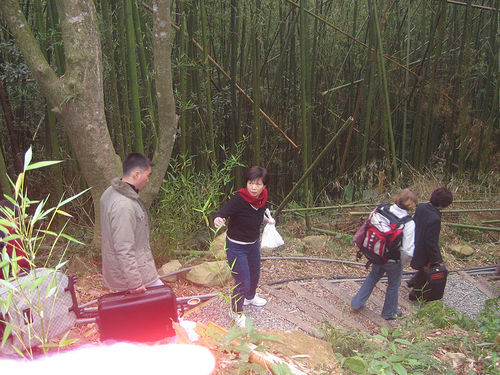<image>
Can you confirm if the woman is behind the plant? No. The woman is not behind the plant. From this viewpoint, the woman appears to be positioned elsewhere in the scene. 